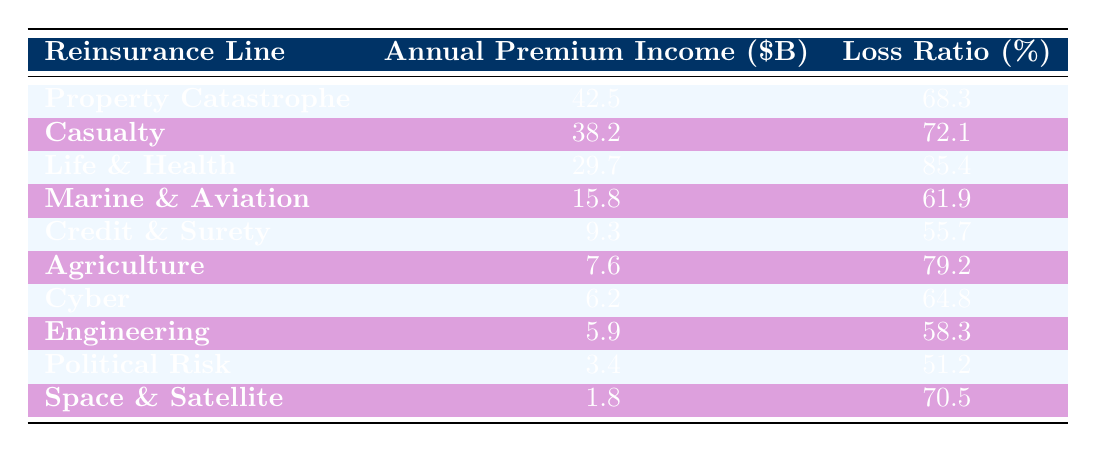What is the annual premium income for the Property Catastrophe line? The table shows that the annual premium income for Property Catastrophe is directly listed under that reinsurance line. According to the table, it is 42.5 billion dollars.
Answer: 42.5 billion dollars What is the loss ratio for the Marine & Aviation line? The loss ratio for Marine & Aviation can be found in the same row as its premium income in the table. It is explicitly stated as 61.9%.
Answer: 61.9% Which reinsurance line has the highest loss ratio? The loss ratios for all reinsurance lines are provided. After checking each one, it's determined that Life & Health has the highest loss ratio at 85.4%.
Answer: Life & Health What is the total annual premium income for the Casualty and Cyber reinsurance lines? The annual premium income for Casualty is 38.2 billion dollars, and for Cyber, it is 6.2 billion dollars. Adding these two values gives us a total of 38.2 + 6.2 = 44.4 billion dollars.
Answer: 44.4 billion dollars Is the loss ratio for Agriculture higher than that for Credit & Surety? The loss ratio for Agriculture is 79.2%, while for Credit & Surety it is 55.7%. Comparing these values, Agriculture has a higher loss ratio.
Answer: Yes Which reinsurance line shows a loss ratio below 60%? By scanning through the loss ratios in the table, Marine & Aviation (61.9%), Cyber (64.8%), Engineering (58.3%), Political Risk (51.2%), and Credit & Surety (55.7%) are listed. Hence, Political Risk and Credit & Surety have loss ratios below 60%.
Answer: Political Risk, Credit & Surety What is the difference in premium income between the Property Catastrophe and Life & Health lines? The premium income for Property Catastrophe is 42.5 billion dollars, and for Life & Health it is 29.7 billion dollars. The difference is 42.5 - 29.7 = 12.8 billion dollars.
Answer: 12.8 billion dollars Is the annual premium income for Space & Satellite greater than that for Agriculture? The premium income for Space & Satellite is 1.8 billion dollars and for Agriculture is 7.6 billion dollars. Since 1.8 is less than 7.6, Space & Satellite's income is not greater.
Answer: No How many reinsurance lines have a loss ratio of 70% or higher? In the table, the loss ratios are examined and found to be 85.4% for Life & Health, 72.1% for Casualty, and 70.5% for Space & Satellite. This totals to 3 reinsurance lines with a loss ratio of 70% or higher.
Answer: 3 